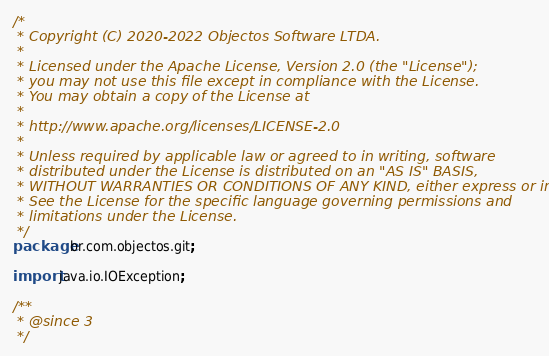<code> <loc_0><loc_0><loc_500><loc_500><_Java_>/*
 * Copyright (C) 2020-2022 Objectos Software LTDA.
 *
 * Licensed under the Apache License, Version 2.0 (the "License");
 * you may not use this file except in compliance with the License.
 * You may obtain a copy of the License at
 *
 * http://www.apache.org/licenses/LICENSE-2.0
 *
 * Unless required by applicable law or agreed to in writing, software
 * distributed under the License is distributed on an "AS IS" BASIS,
 * WITHOUT WARRANTIES OR CONDITIONS OF ANY KIND, either express or implied.
 * See the License for the specific language governing permissions and
 * limitations under the License.
 */
package br.com.objectos.git;

import java.io.IOException;

/**
 * @since 3
 */</code> 